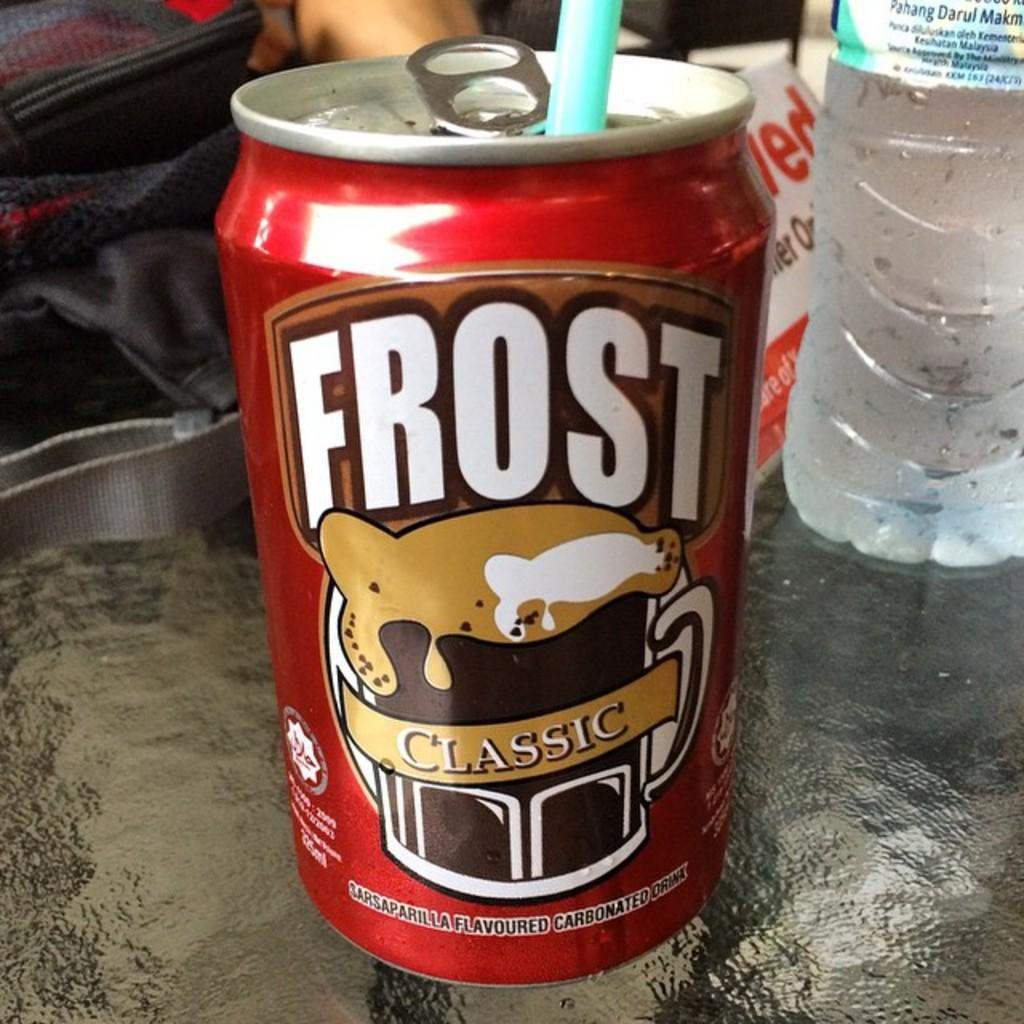<image>
Present a compact description of the photo's key features. A can of Frost Classic has a blue straw in it. 